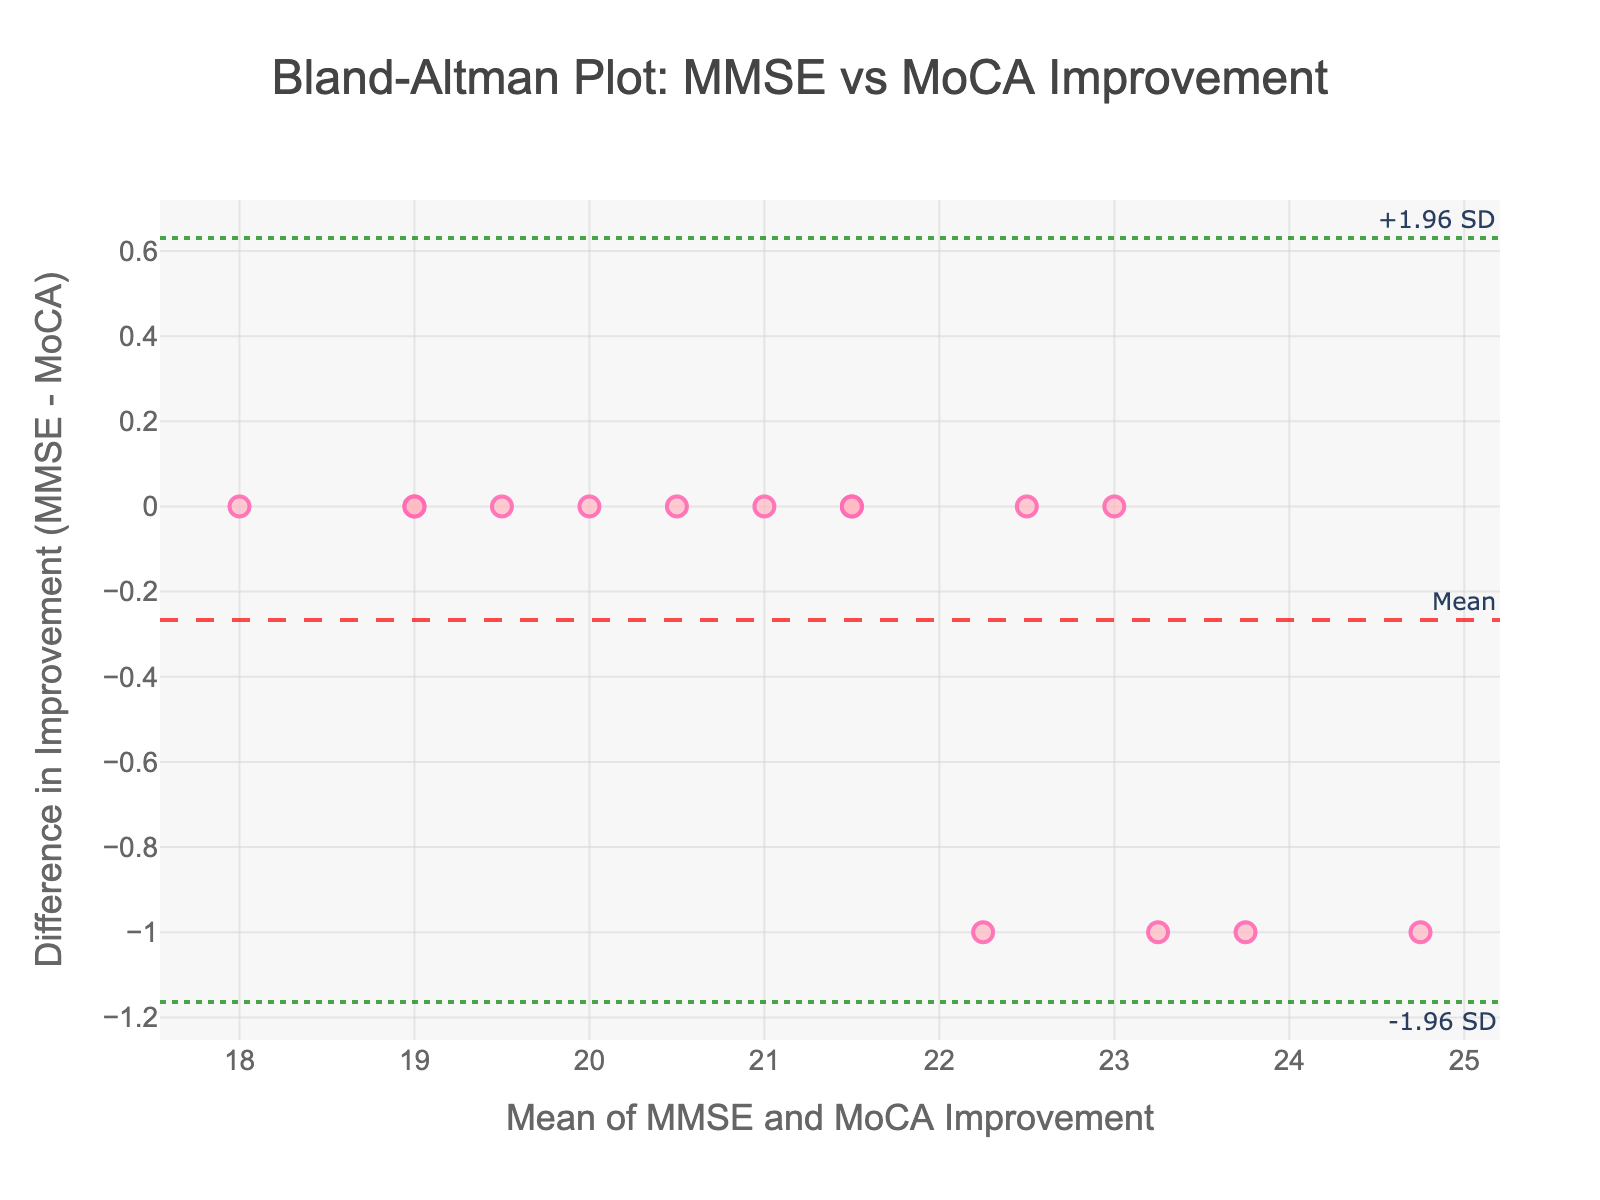What's the title of the figure? The title of the figure is located at the top of the plot in large bold text. It provides a summary of what the plot is depicting.
Answer: Bland-Altman Plot: MMSE vs MoCA Improvement What variables are plotted on the x-axis and y-axis? The x-axis title is "Mean of MMSE and MoCA Improvement" which indicates it is plotting the average of MMSE and MoCA improvements. The y-axis title is "Difference in Improvement (MMSE - MoCA)" which indicates it is plotting the difference between MMSE and MoCA improvements.
Answer: Mean of MMSE and MoCA Improvement; Difference in Improvement (MMSE - MoCA) How many data points are displayed in the plot? By carefully counting the number of markers (points) on the scatter plot, each representing a participant, we can determine the number of data points.
Answer: 15 What is the mean difference in the plot, and where is it indicated? The mean difference is indicated by a dashed horizontal line on the plot, labeled as "Mean" in the top right corner. The line represents the average difference in improvement between MMSE and MoCA scores.
Answer: Mean difference is labeled as "Mean" What are the upper and lower limits of agreement in the plot, and where are they indicated? The upper and lower limits of agreement are represented by dotted horizontal lines. The upper limit is labeled as "+1.96 SD" and the lower limit is labeled as "-1.96 SD", both indicated in green and positioned at the top right and bottom right corners respectively.
Answer: Upper limit: +1.96 SD; Lower limit: -1.96 SD What is the color of the data points in the Bland-Altman plot? The data points in the scatter plot are represented in a specific color with details visible in the plot.
Answer: Light pink with dark pink borders Which individual shows the greatest improvement difference between MMSE and MoCA? To determine this, observe the point furthest from the mean difference line on the y-axis.
Answer: Michael Taylor Are there any participants with similar mean improvements but different differences in improvement? By examining the scatter plot, identify if there are points that align closely on the x-axis (mean improvement) but differ significantly in their y-axis values (difference in improvement).
Answer: Yes Is the majority of the data within the limits of agreement? Look for how many of the points fall between the upper and lower dotted lines representing the limits of agreement.
Answer: Yes Is there a general trend or pattern in the scatter plot? Examine the overall distribution of the points to see if they form any visible pattern, indicating systematic bias or random variability.
Answer: No clear trend or pattern 